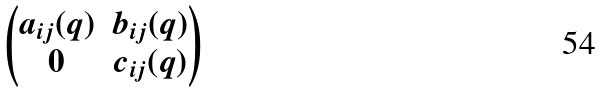Convert formula to latex. <formula><loc_0><loc_0><loc_500><loc_500>\begin{pmatrix} a _ { i j } ( q ) & b _ { i j } ( q ) \\ 0 & c _ { i j } ( q ) \end{pmatrix}</formula> 